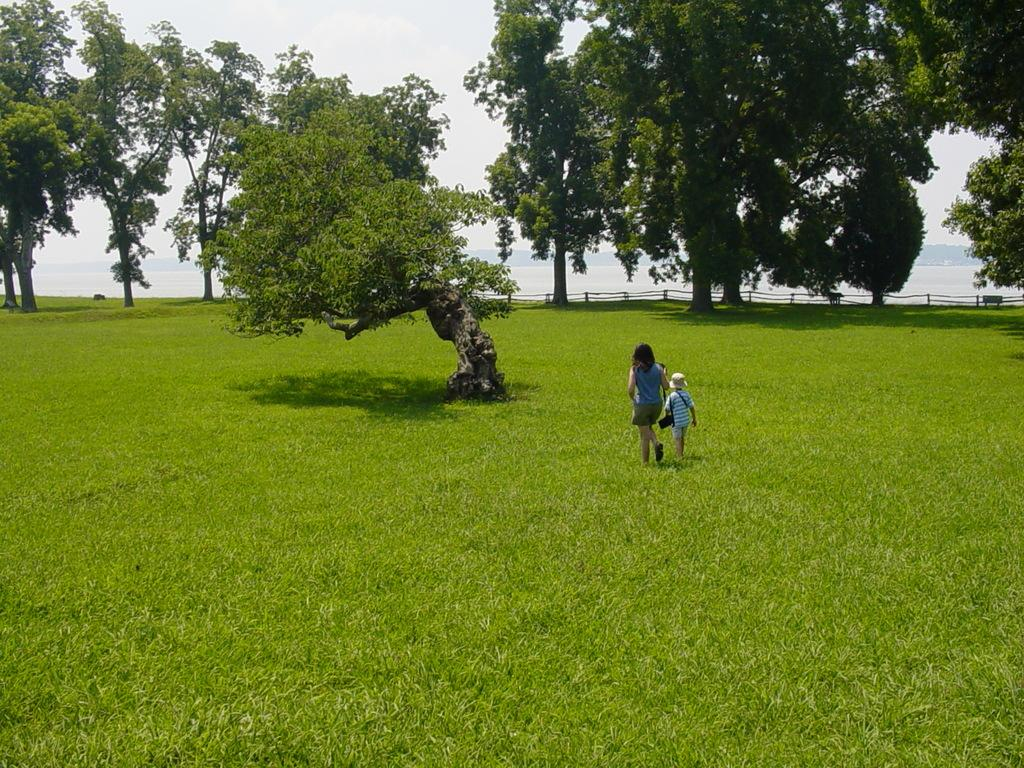Who can be seen in the image? There is a woman and a boy in the image. What are the woman and the boy doing? The woman and the boy are walking. What type of terrain is visible at the bottom of the image? There is grass at the bottom of the image. What can be seen in the background of the image? There are trees and a fence in the background of the image. What is visible at the top of the image? The sky is visible at the top of the image. What type of pin can be seen in the woman's brain in the image? There is no pin or reference to the woman's brain in the image; it only shows her and the boy walking. 